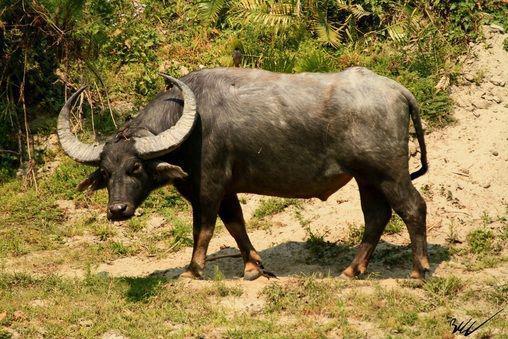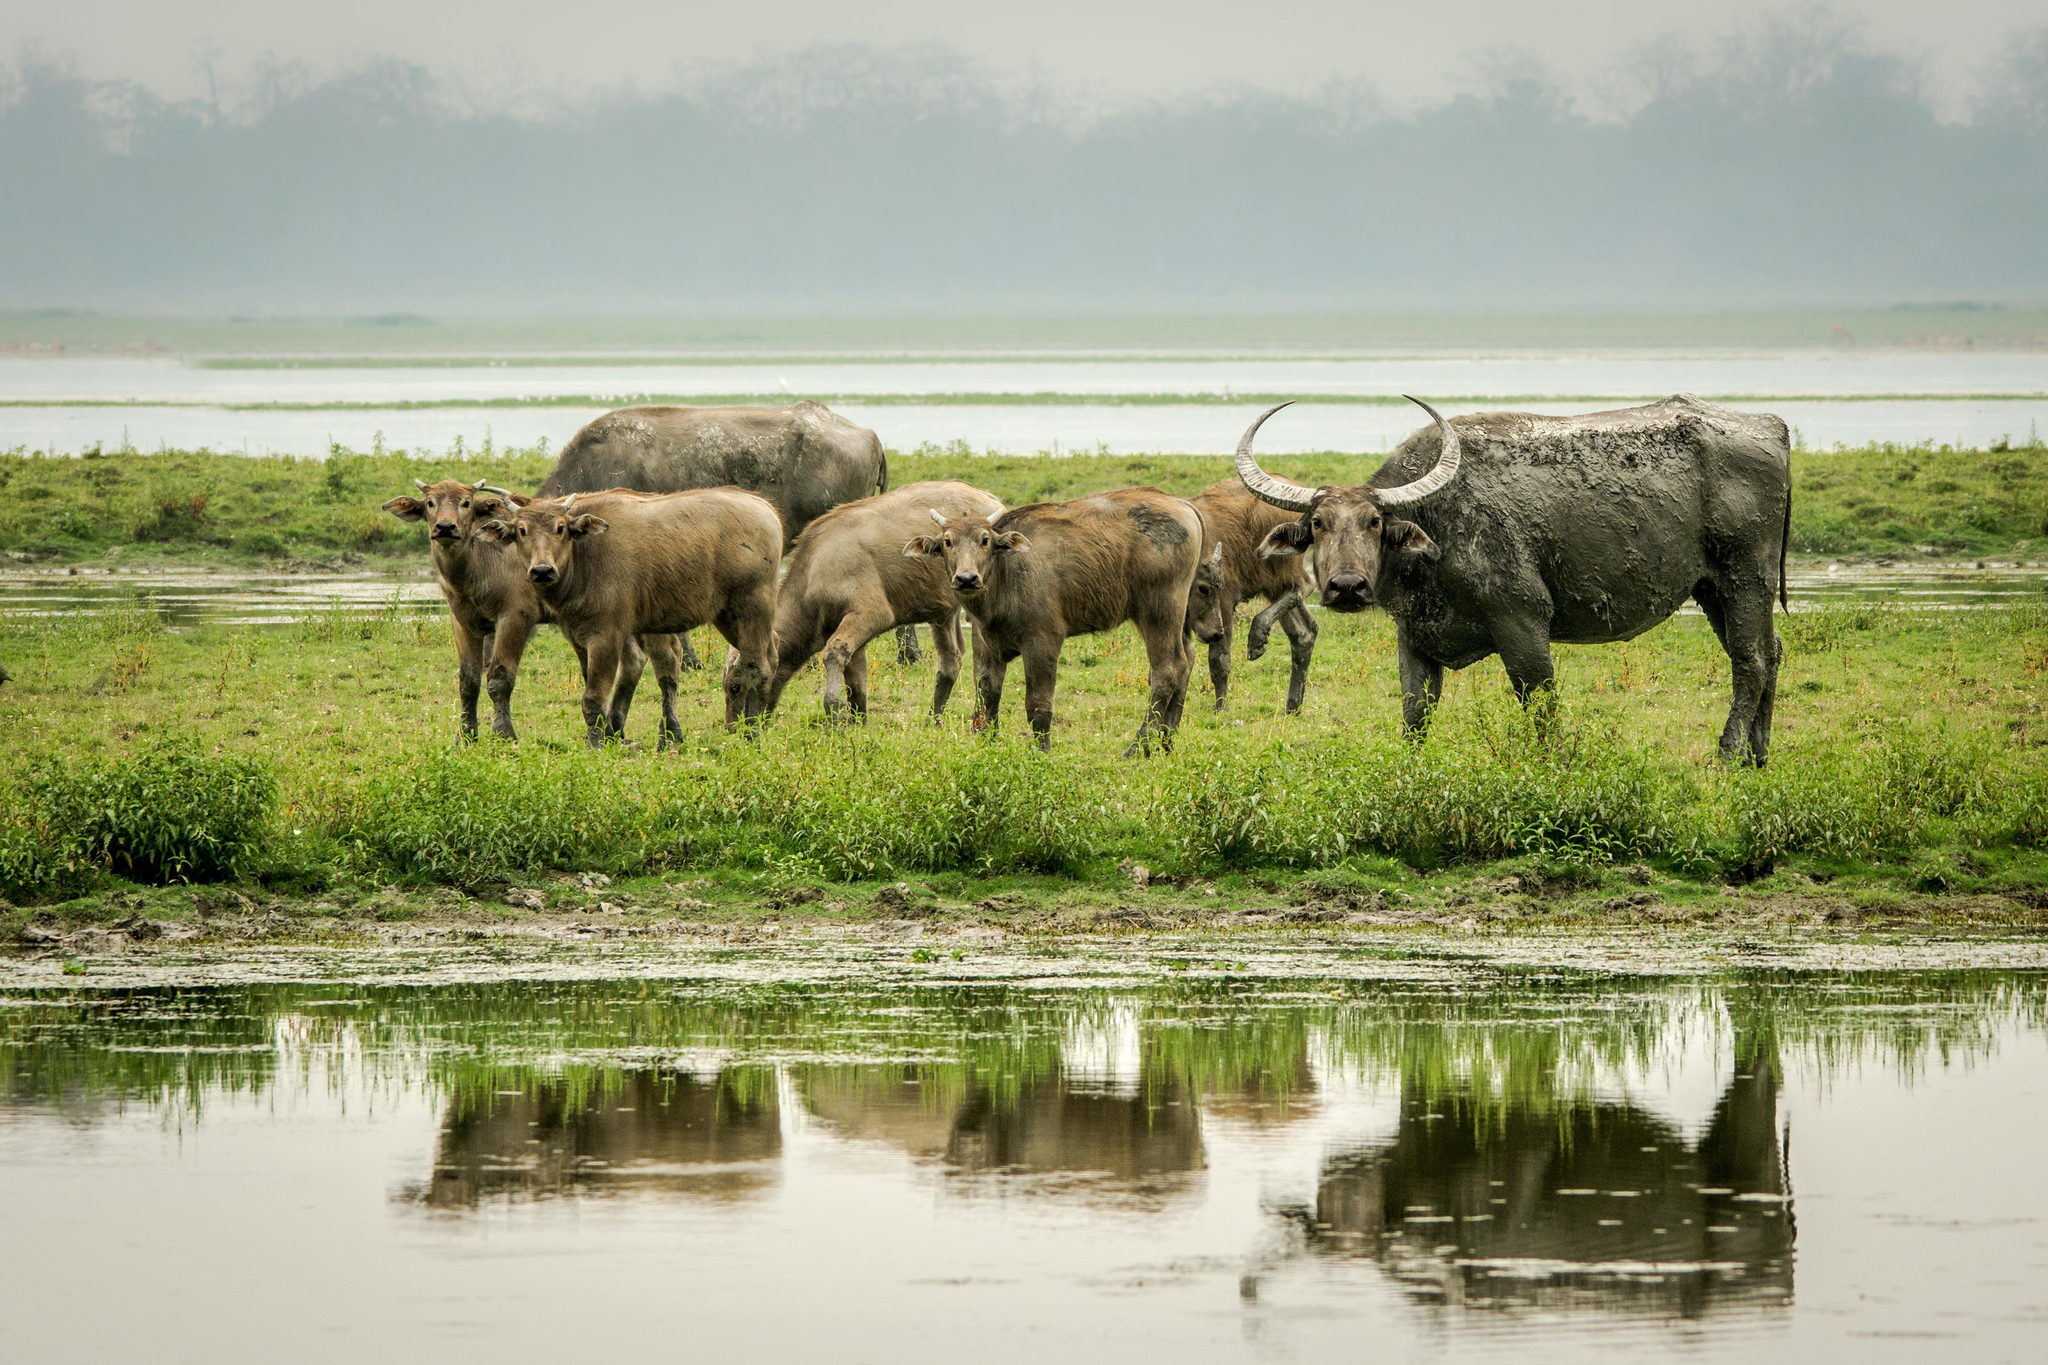The first image is the image on the left, the second image is the image on the right. Evaluate the accuracy of this statement regarding the images: "The righthand image shows exactly one water buffalo, which faces the camera.". Is it true? Answer yes or no. No. The first image is the image on the left, the second image is the image on the right. Evaluate the accuracy of this statement regarding the images: "The right image contains no more than one water buffalo.". Is it true? Answer yes or no. No. 